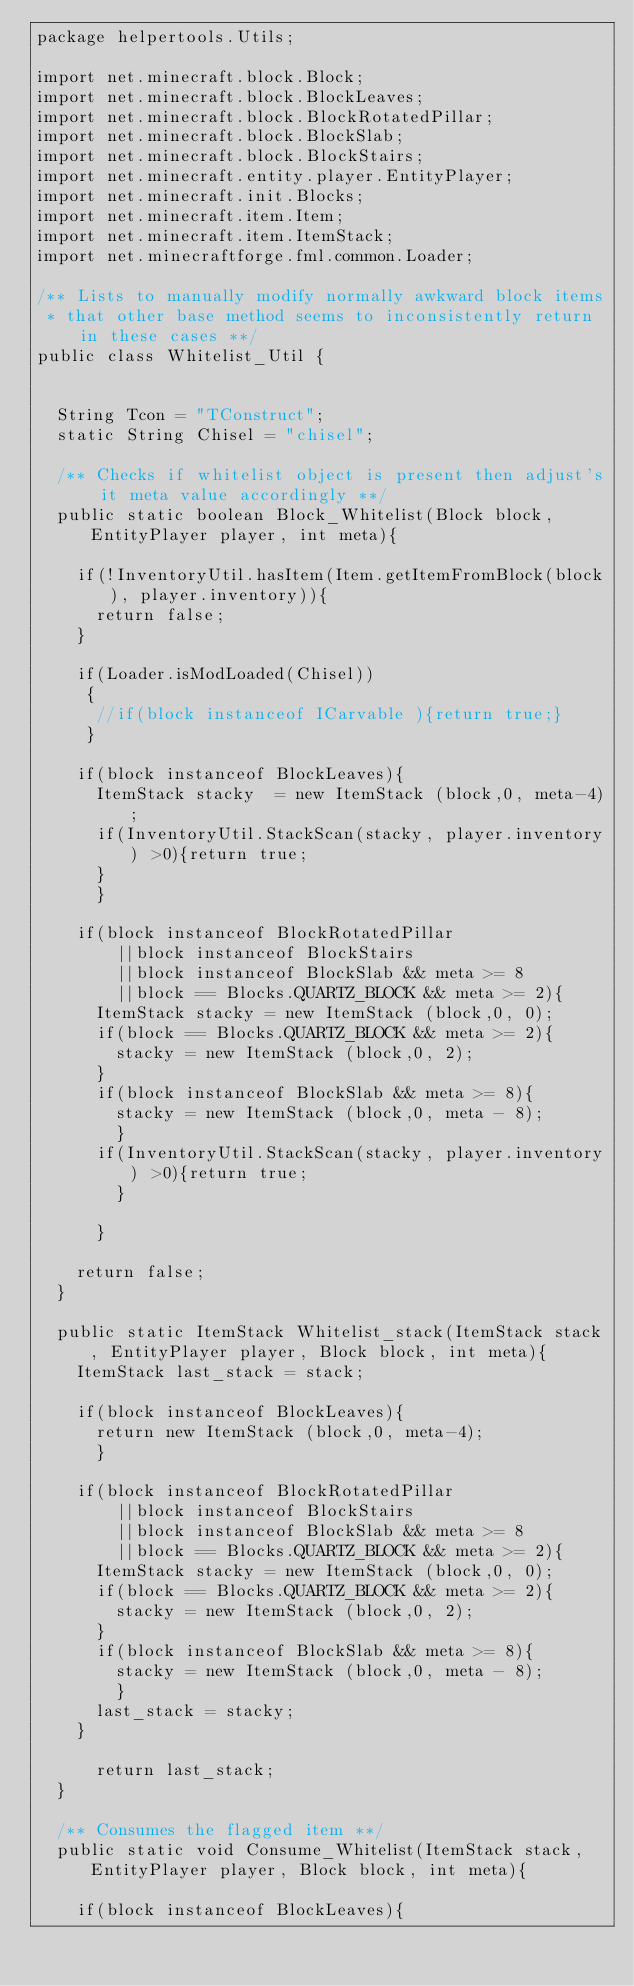<code> <loc_0><loc_0><loc_500><loc_500><_Java_>package helpertools.Utils;

import net.minecraft.block.Block;
import net.minecraft.block.BlockLeaves;
import net.minecraft.block.BlockRotatedPillar;
import net.minecraft.block.BlockSlab;
import net.minecraft.block.BlockStairs;
import net.minecraft.entity.player.EntityPlayer;
import net.minecraft.init.Blocks;
import net.minecraft.item.Item;
import net.minecraft.item.ItemStack;
import net.minecraftforge.fml.common.Loader;

/** Lists to manually modify normally awkward block items
 * that other base method seems to inconsistently return in these cases **/
public class Whitelist_Util {
	
	
	String Tcon = "TConstruct";
	static String Chisel = "chisel";
	
	/** Checks if whitelist object is present then adjust's it meta value accordingly **/
	public static boolean Block_Whitelist(Block block, EntityPlayer player, int meta){
		
		if(!InventoryUtil.hasItem(Item.getItemFromBlock(block), player.inventory)){
			return false;
		}
		
		if(Loader.isModLoaded(Chisel))
		 {
			//if(block instanceof ICarvable ){return true;}
		 }
		
		if(block instanceof BlockLeaves){
			ItemStack stacky  = new ItemStack (block,0, meta-4);
			if(InventoryUtil.StackScan(stacky, player.inventory) >0){return true;
			}
		  }
		
		if(block instanceof BlockRotatedPillar
				||block instanceof BlockStairs
				||block instanceof BlockSlab && meta >= 8
				||block == Blocks.QUARTZ_BLOCK && meta >= 2){
			ItemStack stacky = new ItemStack (block,0, 0);
			if(block == Blocks.QUARTZ_BLOCK && meta >= 2){
				stacky = new ItemStack (block,0, 2);
			}
			if(block instanceof BlockSlab && meta >= 8){
				stacky = new ItemStack (block,0, meta - 8);
			  }
			if(InventoryUtil.StackScan(stacky, player.inventory) >0){return true;
				}
				
			}
	
		return false;
	}
	
	public static ItemStack Whitelist_stack(ItemStack stack, EntityPlayer player, Block block, int meta){
		ItemStack last_stack = stack;
		
		if(block instanceof BlockLeaves){
			return new ItemStack (block,0, meta-4);
		  }
		
		if(block instanceof BlockRotatedPillar
				||block instanceof BlockStairs
				||block instanceof BlockSlab && meta >= 8
				||block == Blocks.QUARTZ_BLOCK && meta >= 2){
			ItemStack stacky = new ItemStack (block,0, 0);
			if(block == Blocks.QUARTZ_BLOCK && meta >= 2){
				stacky = new ItemStack (block,0, 2);
			}
			if(block instanceof BlockSlab && meta >= 8){
				stacky = new ItemStack (block,0, meta - 8);
			  }
			last_stack = stacky;
		}
		
			return last_stack;
	}
	
	/** Consumes the flagged item **/
	public static void Consume_Whitelist(ItemStack stack, EntityPlayer player, Block block, int meta){
		
		if(block instanceof BlockLeaves){</code> 